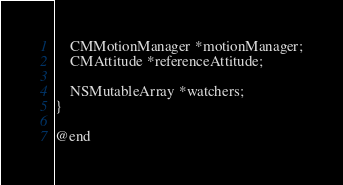<code> <loc_0><loc_0><loc_500><loc_500><_C_>    CMMotionManager *motionManager;
    CMAttitude *referenceAttitude;

    NSMutableArray *watchers;
}

@end
</code> 